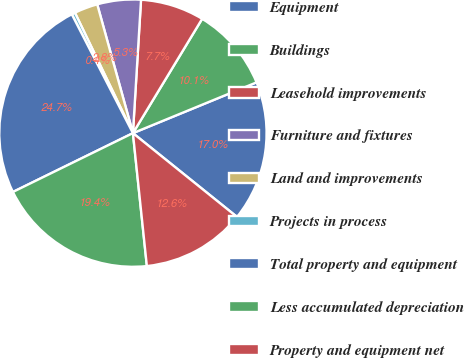Convert chart. <chart><loc_0><loc_0><loc_500><loc_500><pie_chart><fcel>Equipment<fcel>Buildings<fcel>Leasehold improvements<fcel>Furniture and fixtures<fcel>Land and improvements<fcel>Projects in process<fcel>Total property and equipment<fcel>Less accumulated depreciation<fcel>Property and equipment net<nl><fcel>16.99%<fcel>10.13%<fcel>7.7%<fcel>5.27%<fcel>2.84%<fcel>0.42%<fcel>24.69%<fcel>19.41%<fcel>12.55%<nl></chart> 